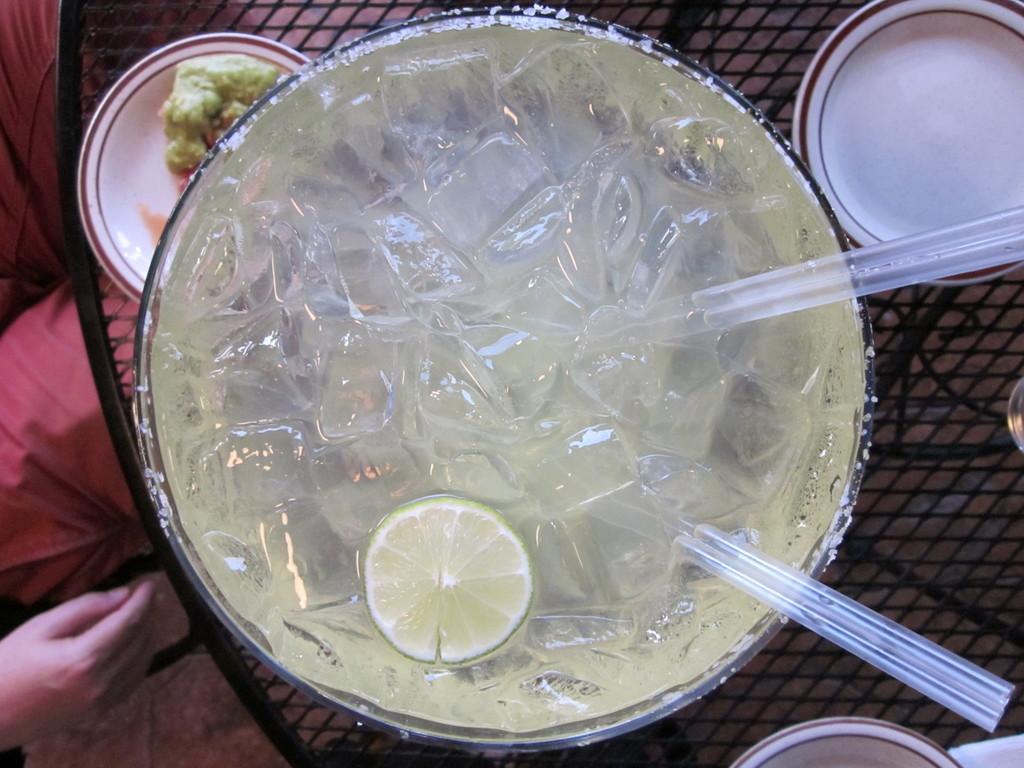Can you describe this image briefly? In this image I can see the glass with ice cubes, lemon and straws in it. To the side I can see the plates. These are on the black color surface. To the left I can see the person. 